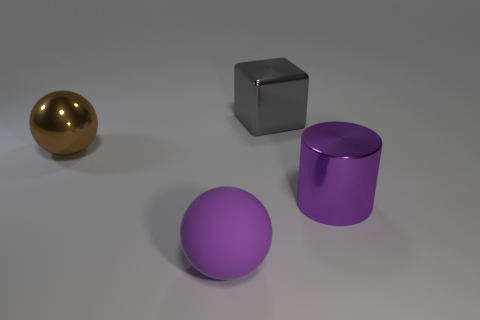How many things are metallic blocks that are behind the big purple cylinder or large cubes that are right of the brown object?
Ensure brevity in your answer.  1. The big brown object that is the same material as the gray thing is what shape?
Ensure brevity in your answer.  Sphere. Is there anything else that is the same color as the large metallic cylinder?
Your response must be concise. Yes. There is another thing that is the same shape as the big brown object; what is its material?
Keep it short and to the point. Rubber. How many other objects are the same size as the block?
Provide a succinct answer. 3. What is the large gray thing made of?
Provide a short and direct response. Metal. Are there more large balls that are in front of the brown thing than small red rubber cylinders?
Keep it short and to the point. Yes. Are there any big cubes?
Make the answer very short. Yes. How many other objects are the same shape as the purple metal thing?
Provide a short and direct response. 0. Is the color of the object in front of the large purple cylinder the same as the large metallic thing on the right side of the big shiny cube?
Your answer should be compact. Yes. 